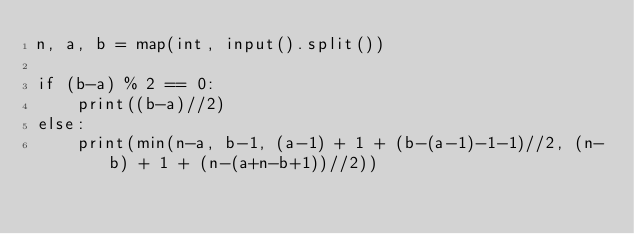<code> <loc_0><loc_0><loc_500><loc_500><_Python_>n, a, b = map(int, input().split())

if (b-a) % 2 == 0:
    print((b-a)//2)
else:
    print(min(n-a, b-1, (a-1) + 1 + (b-(a-1)-1-1)//2, (n-b) + 1 + (n-(a+n-b+1))//2))
</code> 